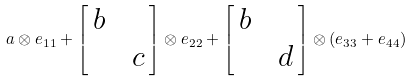Convert formula to latex. <formula><loc_0><loc_0><loc_500><loc_500>a \otimes e _ { 1 1 } + \begin{bmatrix} \, b \, \\ & \, c \, \end{bmatrix} \otimes e _ { 2 2 } + \begin{bmatrix} \, b \, \\ & \, d \, \end{bmatrix} \otimes ( e _ { 3 3 } + e _ { 4 4 } )</formula> 